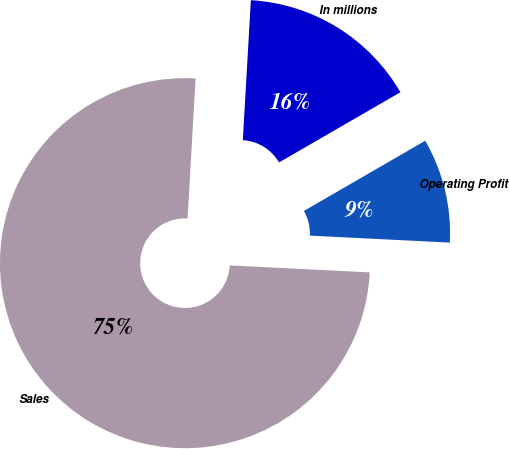Convert chart. <chart><loc_0><loc_0><loc_500><loc_500><pie_chart><fcel>In millions<fcel>Sales<fcel>Operating Profit<nl><fcel>15.74%<fcel>75.13%<fcel>9.14%<nl></chart> 